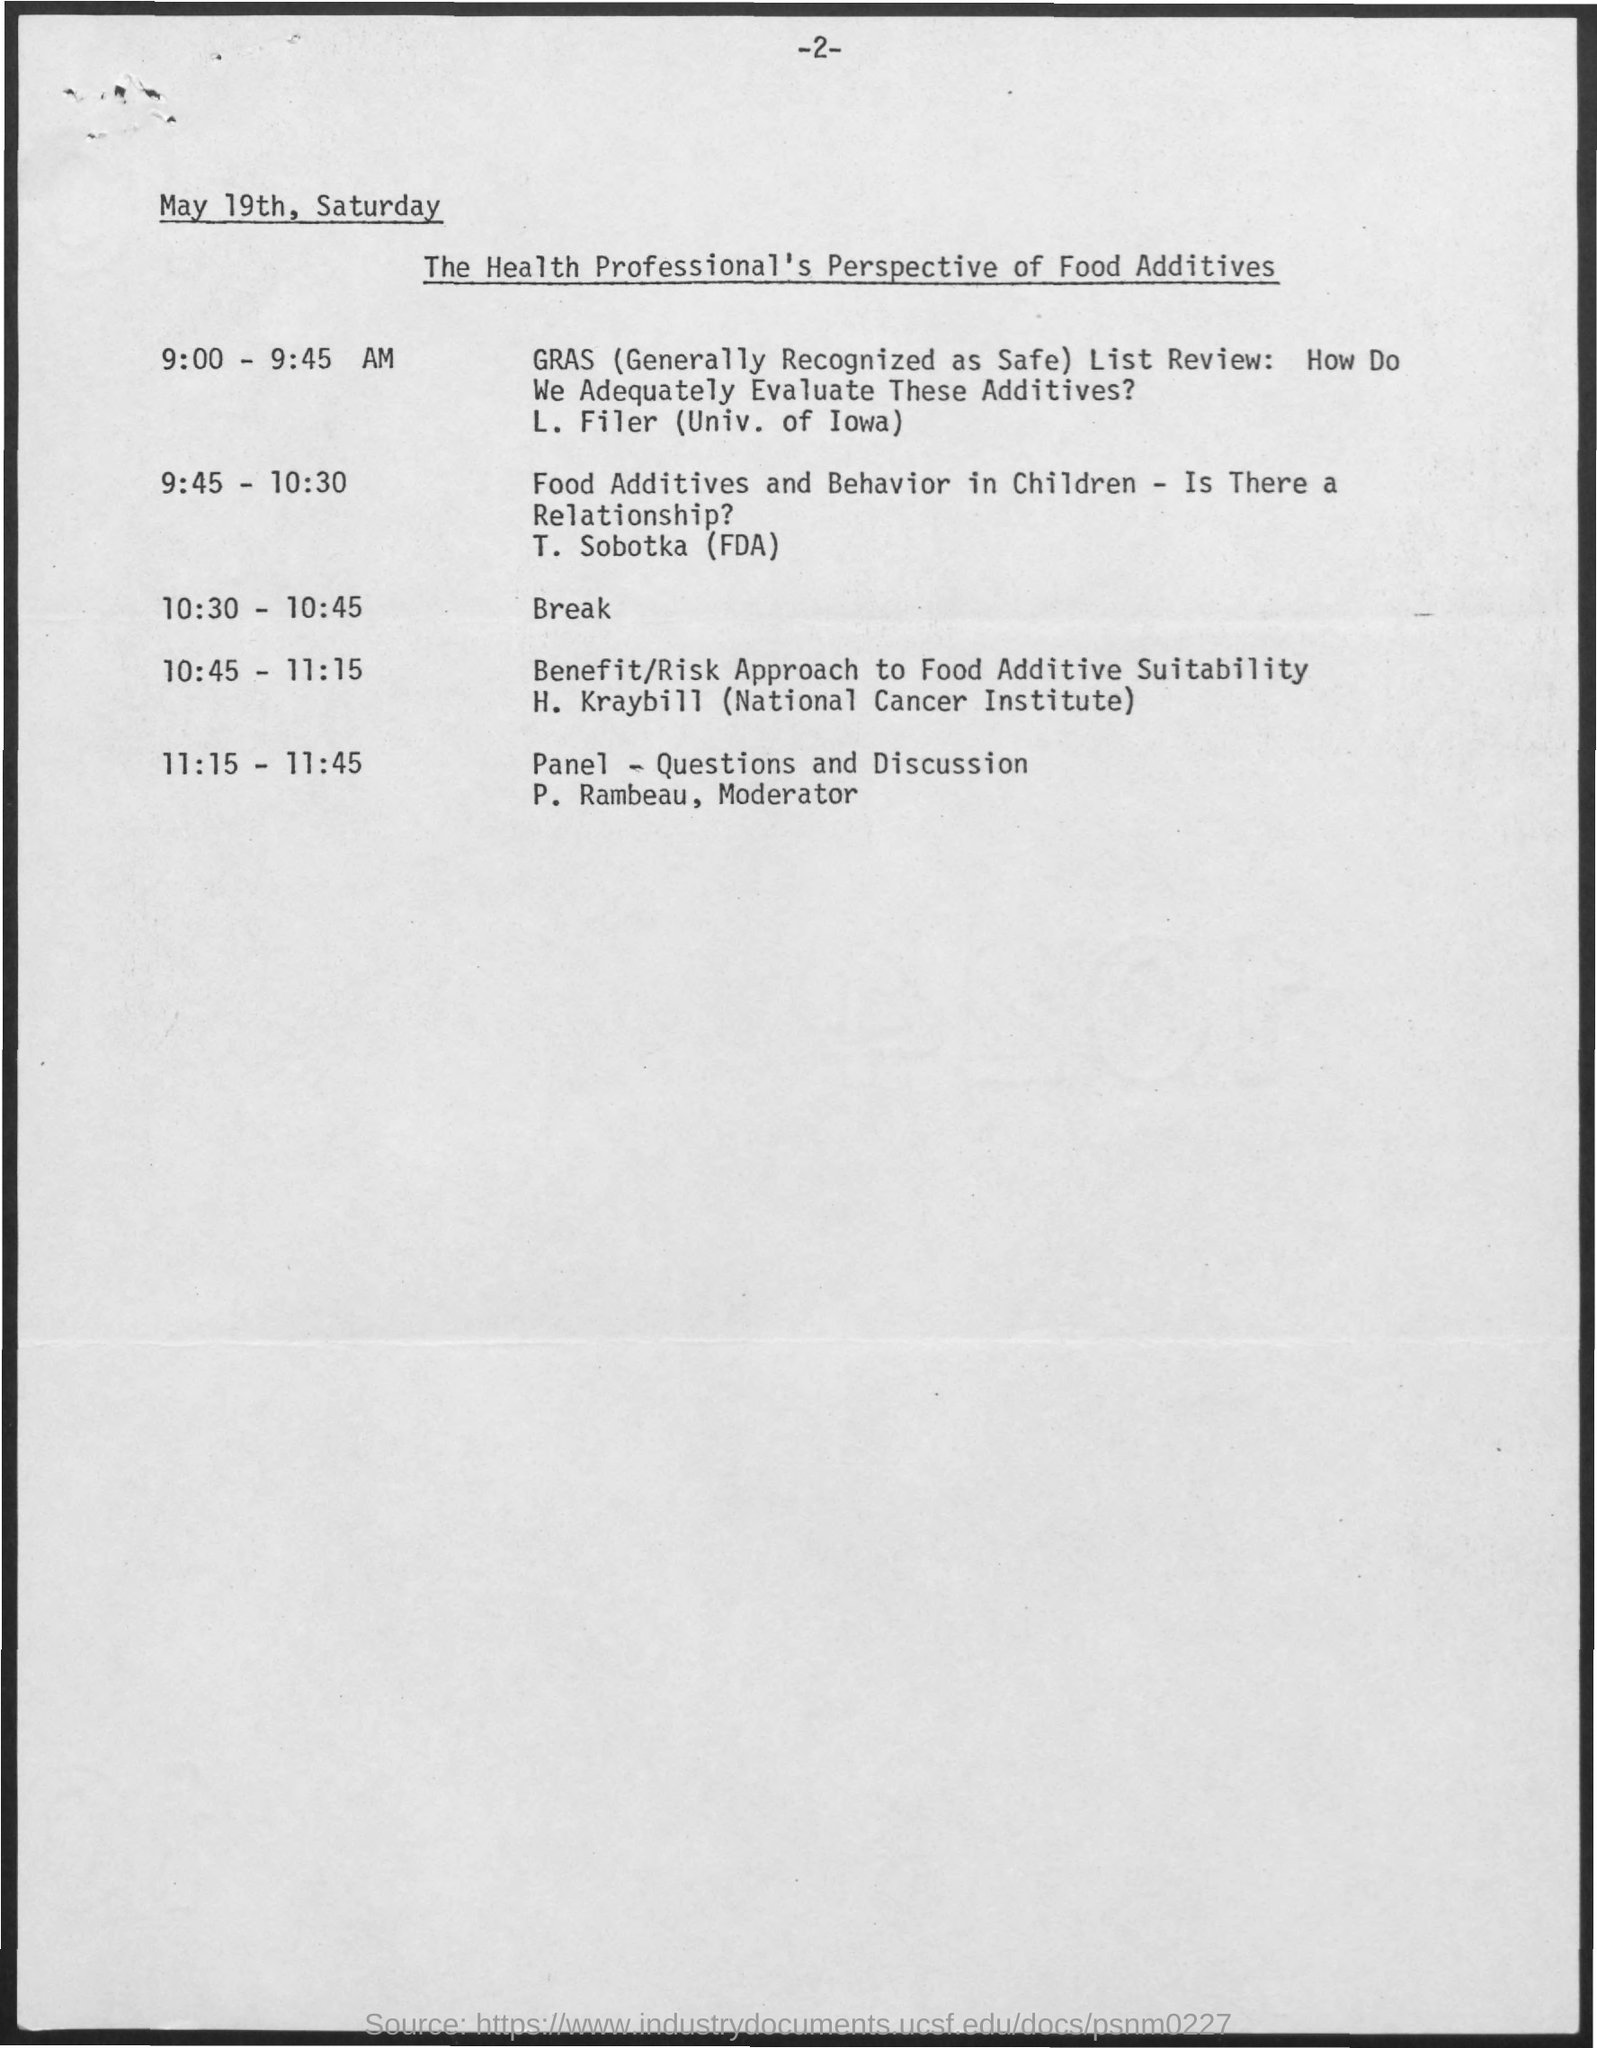Who is referred as the Modeartor for Panel - Questions and Discussion?
Provide a short and direct response. P. Rambeau. What time is the break provided?
Offer a terse response. 10:30 - 10:45. What is the fullform of GRAS?
Your response must be concise. (generally recognized as safe). What ime is the session carried out by T. Sobotka (FDA)?
Offer a very short reply. 9:45 - 10:30. 